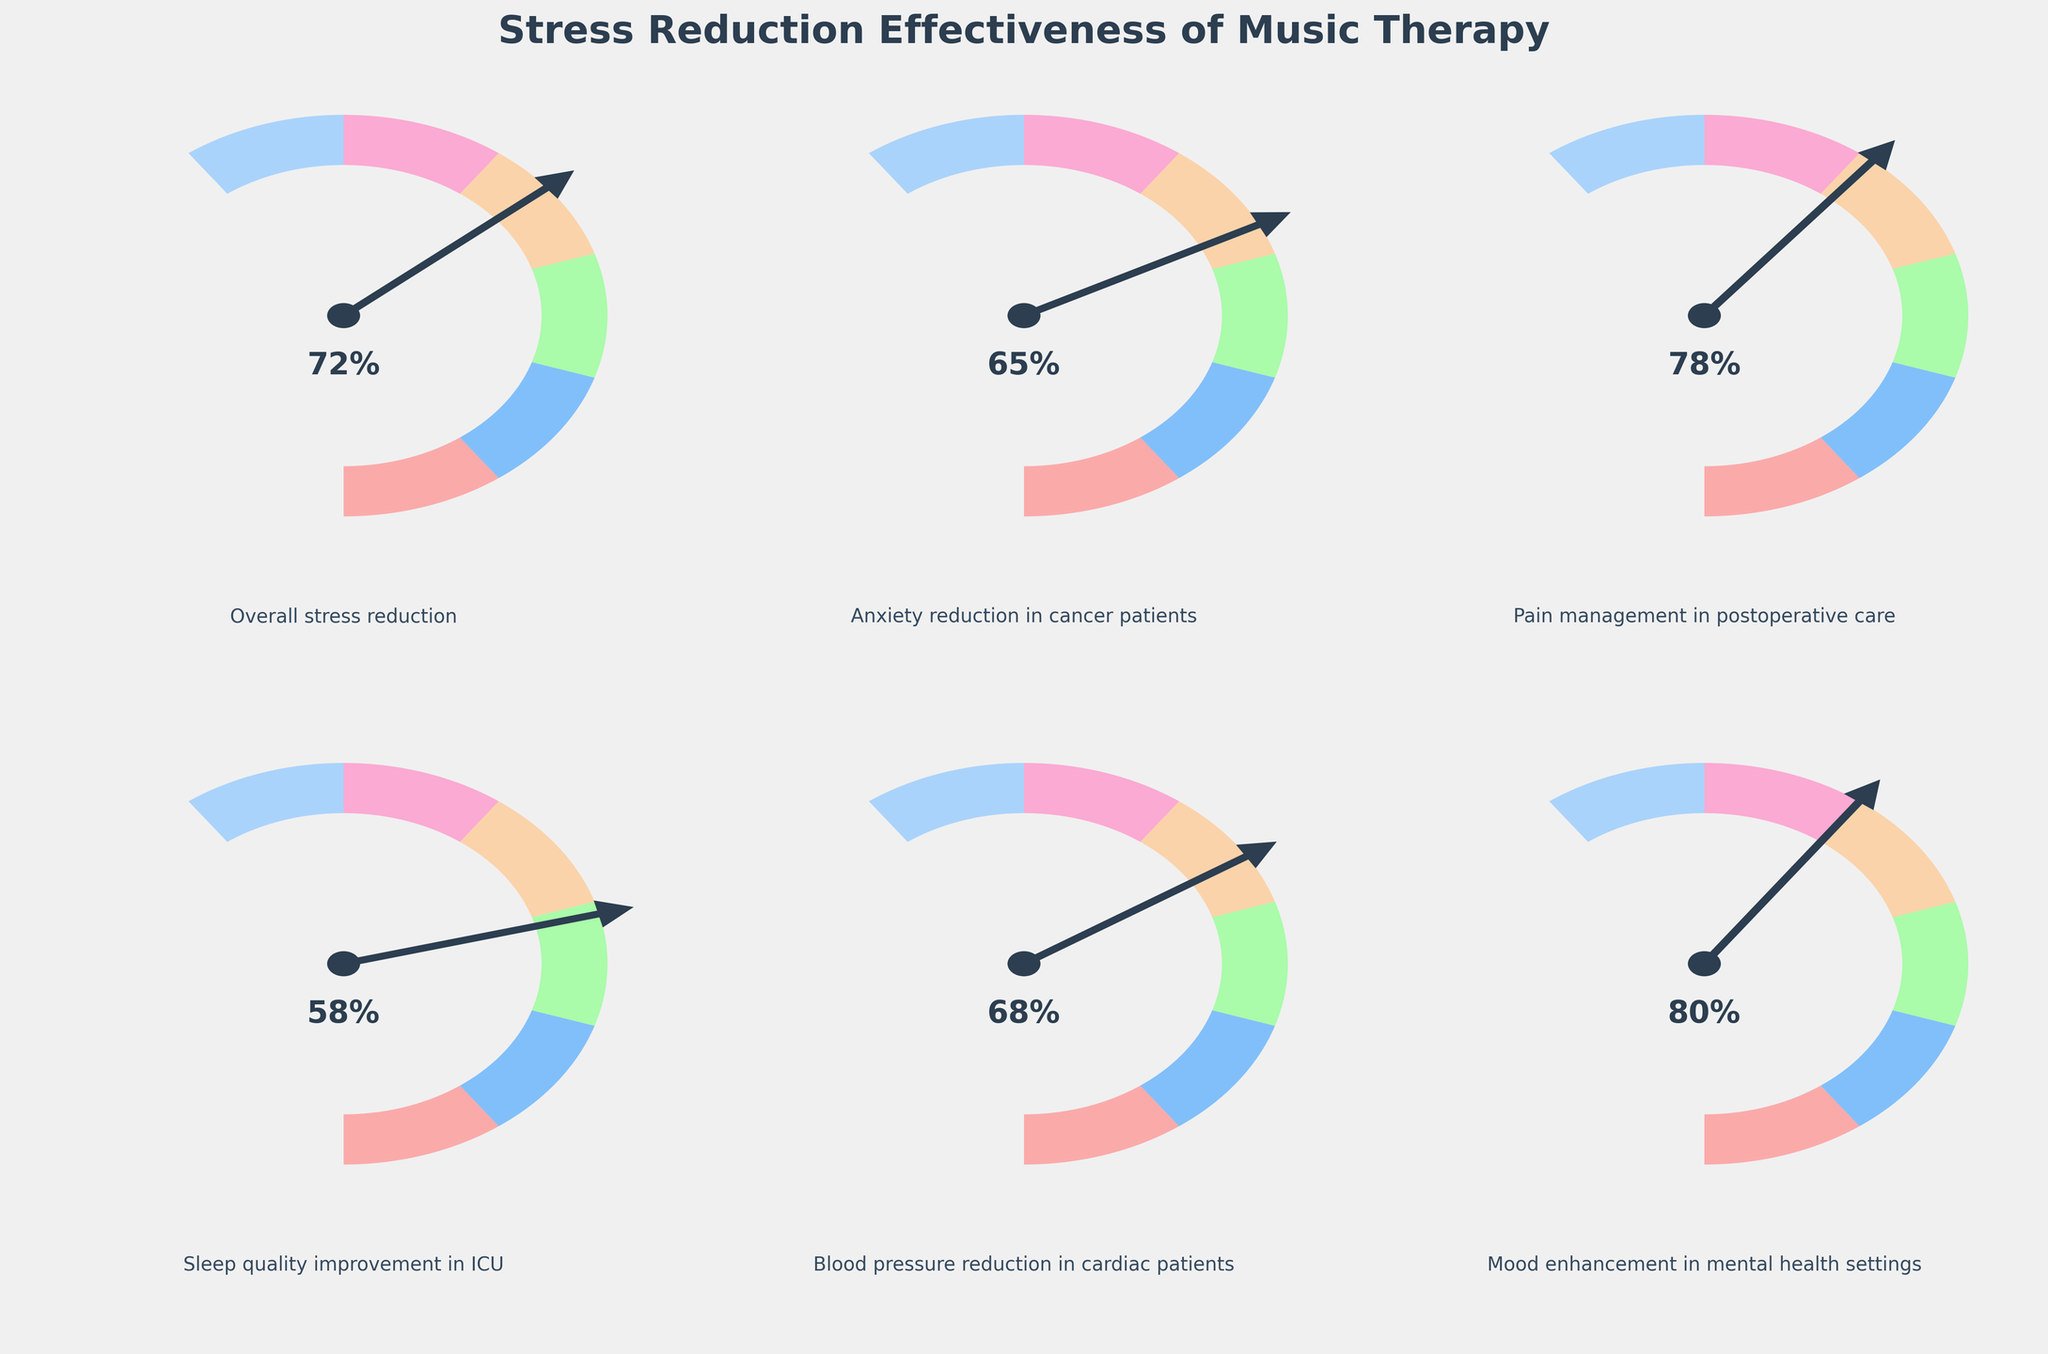What is the title of the figure? The title is displayed at the top center of the figure and provides an overview of what the figure is about.
Answer: Stress Reduction Effectiveness of Music Therapy What percentage value is indicated for anxiety reduction in cancer patients? The anxiety reduction in cancer patients is indicated by the needle's position on the gauge.
Answer: 65% Which category shows the highest effectiveness in terms of percentage? By comparing the needle positions on all the gauge charts, the one with the highest percentage is identifiable.
Answer: Mood enhancement in mental health settings What is the average percentage value across all categories? Sum the percentage values in each category (72 + 65 + 78 + 58 + 68 + 80) and then divide by the number of categories (6) to find the average.
Answer: 70.17% Which category has a lower effectiveness in percentage than blood pressure reduction in cardiac patients but higher than sleep quality improvement in ICU? Compare the percentage values for blood pressure reduction (68%) and sleep quality improvement (58%) with other categories.
Answer: Anxiety reduction in cancer patients What is the range of values for the 'Overall stress reduction' category? The range is from the minimum to the maximum value, displayed on the gauge for this category.
Answer: 0-100 Which categories have effectiveness percentages between 60% and 75% inclusive? Identify the categories whose percentage values fall within the 60-75% range.
Answer: Overall stress reduction, Anxiety reduction in cancer patients, Blood pressure reduction in cardiac patients By how many percentage points does pain management in postoperative care exceed sleep quality improvement in ICU? Subtract the sleep quality improvement percentage (58%) from the pain management percentage (78%) to find the difference.
Answer: 20% Which category shows a slightly lower effectiveness percentage than 'Overall stress reduction'? Find the category with a percentage value just below the overall stress reduction value of 72%.
Answer: Blood pressure reduction in cardiac patients How many categories exhibit effectiveness percentages of 70% or above? Count the number of categories where the percentage value is 70 or higher.
Answer: 3 